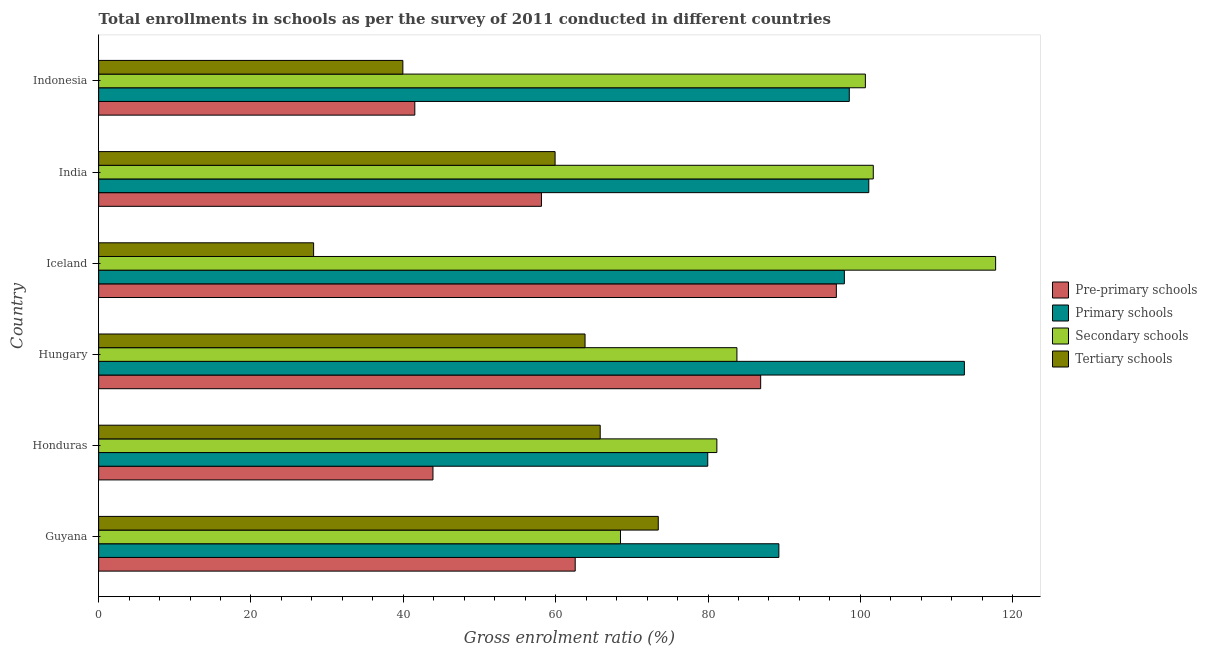How many different coloured bars are there?
Ensure brevity in your answer.  4. Are the number of bars per tick equal to the number of legend labels?
Keep it short and to the point. Yes. What is the label of the 1st group of bars from the top?
Give a very brief answer. Indonesia. In how many cases, is the number of bars for a given country not equal to the number of legend labels?
Keep it short and to the point. 0. What is the gross enrolment ratio in pre-primary schools in Guyana?
Your answer should be compact. 62.57. Across all countries, what is the maximum gross enrolment ratio in pre-primary schools?
Provide a short and direct response. 96.85. Across all countries, what is the minimum gross enrolment ratio in tertiary schools?
Give a very brief answer. 28.22. In which country was the gross enrolment ratio in primary schools minimum?
Ensure brevity in your answer.  Honduras. What is the total gross enrolment ratio in secondary schools in the graph?
Offer a very short reply. 553.58. What is the difference between the gross enrolment ratio in tertiary schools in Hungary and that in India?
Your answer should be very brief. 3.93. What is the difference between the gross enrolment ratio in primary schools in Guyana and the gross enrolment ratio in secondary schools in Iceland?
Your response must be concise. -28.45. What is the average gross enrolment ratio in tertiary schools per country?
Your answer should be very brief. 55.21. What is the difference between the gross enrolment ratio in tertiary schools and gross enrolment ratio in secondary schools in India?
Ensure brevity in your answer.  -41.77. In how many countries, is the gross enrolment ratio in secondary schools greater than 20 %?
Ensure brevity in your answer.  6. What is the ratio of the gross enrolment ratio in secondary schools in Hungary to that in India?
Offer a terse response. 0.82. Is the gross enrolment ratio in primary schools in Guyana less than that in Indonesia?
Your response must be concise. Yes. What is the difference between the highest and the second highest gross enrolment ratio in pre-primary schools?
Your response must be concise. 9.94. What is the difference between the highest and the lowest gross enrolment ratio in tertiary schools?
Offer a terse response. 45.25. Is it the case that in every country, the sum of the gross enrolment ratio in secondary schools and gross enrolment ratio in tertiary schools is greater than the sum of gross enrolment ratio in pre-primary schools and gross enrolment ratio in primary schools?
Make the answer very short. No. What does the 3rd bar from the top in Guyana represents?
Offer a very short reply. Primary schools. What does the 3rd bar from the bottom in Honduras represents?
Keep it short and to the point. Secondary schools. How many bars are there?
Give a very brief answer. 24. Are all the bars in the graph horizontal?
Keep it short and to the point. Yes. Are the values on the major ticks of X-axis written in scientific E-notation?
Provide a short and direct response. No. Where does the legend appear in the graph?
Keep it short and to the point. Center right. What is the title of the graph?
Give a very brief answer. Total enrollments in schools as per the survey of 2011 conducted in different countries. Does "UNAIDS" appear as one of the legend labels in the graph?
Keep it short and to the point. No. What is the label or title of the X-axis?
Ensure brevity in your answer.  Gross enrolment ratio (%). What is the label or title of the Y-axis?
Your response must be concise. Country. What is the Gross enrolment ratio (%) of Pre-primary schools in Guyana?
Offer a terse response. 62.57. What is the Gross enrolment ratio (%) in Primary schools in Guyana?
Offer a very short reply. 89.3. What is the Gross enrolment ratio (%) of Secondary schools in Guyana?
Provide a short and direct response. 68.51. What is the Gross enrolment ratio (%) of Tertiary schools in Guyana?
Offer a very short reply. 73.47. What is the Gross enrolment ratio (%) of Pre-primary schools in Honduras?
Provide a short and direct response. 43.89. What is the Gross enrolment ratio (%) in Primary schools in Honduras?
Offer a terse response. 79.97. What is the Gross enrolment ratio (%) of Secondary schools in Honduras?
Keep it short and to the point. 81.16. What is the Gross enrolment ratio (%) of Tertiary schools in Honduras?
Keep it short and to the point. 65.85. What is the Gross enrolment ratio (%) in Pre-primary schools in Hungary?
Ensure brevity in your answer.  86.91. What is the Gross enrolment ratio (%) in Primary schools in Hungary?
Make the answer very short. 113.66. What is the Gross enrolment ratio (%) of Secondary schools in Hungary?
Your response must be concise. 83.8. What is the Gross enrolment ratio (%) of Tertiary schools in Hungary?
Provide a succinct answer. 63.86. What is the Gross enrolment ratio (%) in Pre-primary schools in Iceland?
Make the answer very short. 96.85. What is the Gross enrolment ratio (%) in Primary schools in Iceland?
Your response must be concise. 97.9. What is the Gross enrolment ratio (%) of Secondary schools in Iceland?
Provide a succinct answer. 117.76. What is the Gross enrolment ratio (%) of Tertiary schools in Iceland?
Ensure brevity in your answer.  28.22. What is the Gross enrolment ratio (%) in Pre-primary schools in India?
Offer a terse response. 58.13. What is the Gross enrolment ratio (%) of Primary schools in India?
Make the answer very short. 101.11. What is the Gross enrolment ratio (%) of Secondary schools in India?
Your answer should be very brief. 101.7. What is the Gross enrolment ratio (%) in Tertiary schools in India?
Provide a succinct answer. 59.92. What is the Gross enrolment ratio (%) of Pre-primary schools in Indonesia?
Offer a terse response. 41.51. What is the Gross enrolment ratio (%) in Primary schools in Indonesia?
Ensure brevity in your answer.  98.55. What is the Gross enrolment ratio (%) of Secondary schools in Indonesia?
Provide a short and direct response. 100.66. What is the Gross enrolment ratio (%) of Tertiary schools in Indonesia?
Provide a succinct answer. 39.94. Across all countries, what is the maximum Gross enrolment ratio (%) of Pre-primary schools?
Keep it short and to the point. 96.85. Across all countries, what is the maximum Gross enrolment ratio (%) of Primary schools?
Offer a terse response. 113.66. Across all countries, what is the maximum Gross enrolment ratio (%) of Secondary schools?
Provide a succinct answer. 117.76. Across all countries, what is the maximum Gross enrolment ratio (%) in Tertiary schools?
Give a very brief answer. 73.47. Across all countries, what is the minimum Gross enrolment ratio (%) in Pre-primary schools?
Keep it short and to the point. 41.51. Across all countries, what is the minimum Gross enrolment ratio (%) in Primary schools?
Offer a very short reply. 79.97. Across all countries, what is the minimum Gross enrolment ratio (%) in Secondary schools?
Offer a terse response. 68.51. Across all countries, what is the minimum Gross enrolment ratio (%) of Tertiary schools?
Provide a succinct answer. 28.22. What is the total Gross enrolment ratio (%) of Pre-primary schools in the graph?
Your response must be concise. 389.86. What is the total Gross enrolment ratio (%) in Primary schools in the graph?
Your answer should be very brief. 580.48. What is the total Gross enrolment ratio (%) of Secondary schools in the graph?
Keep it short and to the point. 553.58. What is the total Gross enrolment ratio (%) of Tertiary schools in the graph?
Keep it short and to the point. 331.26. What is the difference between the Gross enrolment ratio (%) in Pre-primary schools in Guyana and that in Honduras?
Offer a terse response. 18.67. What is the difference between the Gross enrolment ratio (%) in Primary schools in Guyana and that in Honduras?
Provide a short and direct response. 9.34. What is the difference between the Gross enrolment ratio (%) in Secondary schools in Guyana and that in Honduras?
Provide a succinct answer. -12.65. What is the difference between the Gross enrolment ratio (%) of Tertiary schools in Guyana and that in Honduras?
Offer a very short reply. 7.62. What is the difference between the Gross enrolment ratio (%) in Pre-primary schools in Guyana and that in Hungary?
Provide a succinct answer. -24.35. What is the difference between the Gross enrolment ratio (%) of Primary schools in Guyana and that in Hungary?
Ensure brevity in your answer.  -24.35. What is the difference between the Gross enrolment ratio (%) in Secondary schools in Guyana and that in Hungary?
Keep it short and to the point. -15.29. What is the difference between the Gross enrolment ratio (%) of Tertiary schools in Guyana and that in Hungary?
Provide a short and direct response. 9.61. What is the difference between the Gross enrolment ratio (%) in Pre-primary schools in Guyana and that in Iceland?
Keep it short and to the point. -34.28. What is the difference between the Gross enrolment ratio (%) of Primary schools in Guyana and that in Iceland?
Offer a very short reply. -8.6. What is the difference between the Gross enrolment ratio (%) of Secondary schools in Guyana and that in Iceland?
Your response must be concise. -49.25. What is the difference between the Gross enrolment ratio (%) in Tertiary schools in Guyana and that in Iceland?
Provide a succinct answer. 45.25. What is the difference between the Gross enrolment ratio (%) in Pre-primary schools in Guyana and that in India?
Give a very brief answer. 4.43. What is the difference between the Gross enrolment ratio (%) of Primary schools in Guyana and that in India?
Offer a very short reply. -11.8. What is the difference between the Gross enrolment ratio (%) in Secondary schools in Guyana and that in India?
Your response must be concise. -33.19. What is the difference between the Gross enrolment ratio (%) of Tertiary schools in Guyana and that in India?
Offer a terse response. 13.55. What is the difference between the Gross enrolment ratio (%) of Pre-primary schools in Guyana and that in Indonesia?
Provide a short and direct response. 21.06. What is the difference between the Gross enrolment ratio (%) in Primary schools in Guyana and that in Indonesia?
Your answer should be very brief. -9.24. What is the difference between the Gross enrolment ratio (%) in Secondary schools in Guyana and that in Indonesia?
Your answer should be very brief. -32.15. What is the difference between the Gross enrolment ratio (%) of Tertiary schools in Guyana and that in Indonesia?
Offer a very short reply. 33.53. What is the difference between the Gross enrolment ratio (%) of Pre-primary schools in Honduras and that in Hungary?
Offer a very short reply. -43.02. What is the difference between the Gross enrolment ratio (%) in Primary schools in Honduras and that in Hungary?
Make the answer very short. -33.69. What is the difference between the Gross enrolment ratio (%) in Secondary schools in Honduras and that in Hungary?
Your answer should be very brief. -2.63. What is the difference between the Gross enrolment ratio (%) of Tertiary schools in Honduras and that in Hungary?
Your answer should be compact. 1.99. What is the difference between the Gross enrolment ratio (%) of Pre-primary schools in Honduras and that in Iceland?
Offer a terse response. -52.96. What is the difference between the Gross enrolment ratio (%) of Primary schools in Honduras and that in Iceland?
Your response must be concise. -17.93. What is the difference between the Gross enrolment ratio (%) in Secondary schools in Honduras and that in Iceland?
Your answer should be compact. -36.6. What is the difference between the Gross enrolment ratio (%) of Tertiary schools in Honduras and that in Iceland?
Your response must be concise. 37.62. What is the difference between the Gross enrolment ratio (%) of Pre-primary schools in Honduras and that in India?
Your answer should be compact. -14.24. What is the difference between the Gross enrolment ratio (%) of Primary schools in Honduras and that in India?
Give a very brief answer. -21.14. What is the difference between the Gross enrolment ratio (%) of Secondary schools in Honduras and that in India?
Offer a terse response. -20.54. What is the difference between the Gross enrolment ratio (%) in Tertiary schools in Honduras and that in India?
Make the answer very short. 5.92. What is the difference between the Gross enrolment ratio (%) of Pre-primary schools in Honduras and that in Indonesia?
Your response must be concise. 2.38. What is the difference between the Gross enrolment ratio (%) of Primary schools in Honduras and that in Indonesia?
Your answer should be compact. -18.58. What is the difference between the Gross enrolment ratio (%) in Secondary schools in Honduras and that in Indonesia?
Your response must be concise. -19.5. What is the difference between the Gross enrolment ratio (%) of Tertiary schools in Honduras and that in Indonesia?
Provide a succinct answer. 25.91. What is the difference between the Gross enrolment ratio (%) in Pre-primary schools in Hungary and that in Iceland?
Ensure brevity in your answer.  -9.94. What is the difference between the Gross enrolment ratio (%) in Primary schools in Hungary and that in Iceland?
Provide a succinct answer. 15.76. What is the difference between the Gross enrolment ratio (%) of Secondary schools in Hungary and that in Iceland?
Provide a succinct answer. -33.96. What is the difference between the Gross enrolment ratio (%) of Tertiary schools in Hungary and that in Iceland?
Keep it short and to the point. 35.63. What is the difference between the Gross enrolment ratio (%) of Pre-primary schools in Hungary and that in India?
Your answer should be compact. 28.78. What is the difference between the Gross enrolment ratio (%) in Primary schools in Hungary and that in India?
Offer a very short reply. 12.55. What is the difference between the Gross enrolment ratio (%) in Secondary schools in Hungary and that in India?
Your answer should be very brief. -17.9. What is the difference between the Gross enrolment ratio (%) of Tertiary schools in Hungary and that in India?
Offer a very short reply. 3.93. What is the difference between the Gross enrolment ratio (%) in Pre-primary schools in Hungary and that in Indonesia?
Make the answer very short. 45.41. What is the difference between the Gross enrolment ratio (%) of Primary schools in Hungary and that in Indonesia?
Make the answer very short. 15.11. What is the difference between the Gross enrolment ratio (%) in Secondary schools in Hungary and that in Indonesia?
Provide a succinct answer. -16.86. What is the difference between the Gross enrolment ratio (%) of Tertiary schools in Hungary and that in Indonesia?
Offer a very short reply. 23.92. What is the difference between the Gross enrolment ratio (%) in Pre-primary schools in Iceland and that in India?
Ensure brevity in your answer.  38.72. What is the difference between the Gross enrolment ratio (%) of Primary schools in Iceland and that in India?
Your answer should be very brief. -3.21. What is the difference between the Gross enrolment ratio (%) of Secondary schools in Iceland and that in India?
Keep it short and to the point. 16.06. What is the difference between the Gross enrolment ratio (%) in Tertiary schools in Iceland and that in India?
Provide a succinct answer. -31.7. What is the difference between the Gross enrolment ratio (%) of Pre-primary schools in Iceland and that in Indonesia?
Ensure brevity in your answer.  55.34. What is the difference between the Gross enrolment ratio (%) of Primary schools in Iceland and that in Indonesia?
Your response must be concise. -0.65. What is the difference between the Gross enrolment ratio (%) of Secondary schools in Iceland and that in Indonesia?
Keep it short and to the point. 17.1. What is the difference between the Gross enrolment ratio (%) of Tertiary schools in Iceland and that in Indonesia?
Offer a terse response. -11.72. What is the difference between the Gross enrolment ratio (%) in Pre-primary schools in India and that in Indonesia?
Give a very brief answer. 16.63. What is the difference between the Gross enrolment ratio (%) in Primary schools in India and that in Indonesia?
Keep it short and to the point. 2.56. What is the difference between the Gross enrolment ratio (%) of Secondary schools in India and that in Indonesia?
Your response must be concise. 1.04. What is the difference between the Gross enrolment ratio (%) of Tertiary schools in India and that in Indonesia?
Provide a succinct answer. 19.99. What is the difference between the Gross enrolment ratio (%) of Pre-primary schools in Guyana and the Gross enrolment ratio (%) of Primary schools in Honduras?
Make the answer very short. -17.4. What is the difference between the Gross enrolment ratio (%) in Pre-primary schools in Guyana and the Gross enrolment ratio (%) in Secondary schools in Honduras?
Your answer should be compact. -18.6. What is the difference between the Gross enrolment ratio (%) in Pre-primary schools in Guyana and the Gross enrolment ratio (%) in Tertiary schools in Honduras?
Provide a succinct answer. -3.28. What is the difference between the Gross enrolment ratio (%) in Primary schools in Guyana and the Gross enrolment ratio (%) in Secondary schools in Honduras?
Offer a terse response. 8.14. What is the difference between the Gross enrolment ratio (%) in Primary schools in Guyana and the Gross enrolment ratio (%) in Tertiary schools in Honduras?
Your response must be concise. 23.46. What is the difference between the Gross enrolment ratio (%) of Secondary schools in Guyana and the Gross enrolment ratio (%) of Tertiary schools in Honduras?
Offer a very short reply. 2.66. What is the difference between the Gross enrolment ratio (%) in Pre-primary schools in Guyana and the Gross enrolment ratio (%) in Primary schools in Hungary?
Provide a short and direct response. -51.09. What is the difference between the Gross enrolment ratio (%) of Pre-primary schools in Guyana and the Gross enrolment ratio (%) of Secondary schools in Hungary?
Provide a succinct answer. -21.23. What is the difference between the Gross enrolment ratio (%) in Pre-primary schools in Guyana and the Gross enrolment ratio (%) in Tertiary schools in Hungary?
Ensure brevity in your answer.  -1.29. What is the difference between the Gross enrolment ratio (%) in Primary schools in Guyana and the Gross enrolment ratio (%) in Secondary schools in Hungary?
Offer a terse response. 5.51. What is the difference between the Gross enrolment ratio (%) of Primary schools in Guyana and the Gross enrolment ratio (%) of Tertiary schools in Hungary?
Give a very brief answer. 25.45. What is the difference between the Gross enrolment ratio (%) of Secondary schools in Guyana and the Gross enrolment ratio (%) of Tertiary schools in Hungary?
Make the answer very short. 4.65. What is the difference between the Gross enrolment ratio (%) in Pre-primary schools in Guyana and the Gross enrolment ratio (%) in Primary schools in Iceland?
Your answer should be compact. -35.33. What is the difference between the Gross enrolment ratio (%) of Pre-primary schools in Guyana and the Gross enrolment ratio (%) of Secondary schools in Iceland?
Your answer should be very brief. -55.19. What is the difference between the Gross enrolment ratio (%) of Pre-primary schools in Guyana and the Gross enrolment ratio (%) of Tertiary schools in Iceland?
Offer a terse response. 34.34. What is the difference between the Gross enrolment ratio (%) of Primary schools in Guyana and the Gross enrolment ratio (%) of Secondary schools in Iceland?
Your answer should be very brief. -28.45. What is the difference between the Gross enrolment ratio (%) of Primary schools in Guyana and the Gross enrolment ratio (%) of Tertiary schools in Iceland?
Offer a very short reply. 61.08. What is the difference between the Gross enrolment ratio (%) of Secondary schools in Guyana and the Gross enrolment ratio (%) of Tertiary schools in Iceland?
Make the answer very short. 40.29. What is the difference between the Gross enrolment ratio (%) in Pre-primary schools in Guyana and the Gross enrolment ratio (%) in Primary schools in India?
Make the answer very short. -38.54. What is the difference between the Gross enrolment ratio (%) of Pre-primary schools in Guyana and the Gross enrolment ratio (%) of Secondary schools in India?
Offer a terse response. -39.13. What is the difference between the Gross enrolment ratio (%) of Pre-primary schools in Guyana and the Gross enrolment ratio (%) of Tertiary schools in India?
Keep it short and to the point. 2.64. What is the difference between the Gross enrolment ratio (%) in Primary schools in Guyana and the Gross enrolment ratio (%) in Secondary schools in India?
Offer a terse response. -12.39. What is the difference between the Gross enrolment ratio (%) in Primary schools in Guyana and the Gross enrolment ratio (%) in Tertiary schools in India?
Provide a short and direct response. 29.38. What is the difference between the Gross enrolment ratio (%) in Secondary schools in Guyana and the Gross enrolment ratio (%) in Tertiary schools in India?
Ensure brevity in your answer.  8.59. What is the difference between the Gross enrolment ratio (%) in Pre-primary schools in Guyana and the Gross enrolment ratio (%) in Primary schools in Indonesia?
Keep it short and to the point. -35.98. What is the difference between the Gross enrolment ratio (%) in Pre-primary schools in Guyana and the Gross enrolment ratio (%) in Secondary schools in Indonesia?
Your answer should be compact. -38.09. What is the difference between the Gross enrolment ratio (%) in Pre-primary schools in Guyana and the Gross enrolment ratio (%) in Tertiary schools in Indonesia?
Offer a terse response. 22.63. What is the difference between the Gross enrolment ratio (%) of Primary schools in Guyana and the Gross enrolment ratio (%) of Secondary schools in Indonesia?
Offer a very short reply. -11.35. What is the difference between the Gross enrolment ratio (%) of Primary schools in Guyana and the Gross enrolment ratio (%) of Tertiary schools in Indonesia?
Your answer should be compact. 49.37. What is the difference between the Gross enrolment ratio (%) in Secondary schools in Guyana and the Gross enrolment ratio (%) in Tertiary schools in Indonesia?
Offer a very short reply. 28.57. What is the difference between the Gross enrolment ratio (%) of Pre-primary schools in Honduras and the Gross enrolment ratio (%) of Primary schools in Hungary?
Provide a short and direct response. -69.76. What is the difference between the Gross enrolment ratio (%) of Pre-primary schools in Honduras and the Gross enrolment ratio (%) of Secondary schools in Hungary?
Keep it short and to the point. -39.91. What is the difference between the Gross enrolment ratio (%) in Pre-primary schools in Honduras and the Gross enrolment ratio (%) in Tertiary schools in Hungary?
Give a very brief answer. -19.97. What is the difference between the Gross enrolment ratio (%) of Primary schools in Honduras and the Gross enrolment ratio (%) of Secondary schools in Hungary?
Provide a succinct answer. -3.83. What is the difference between the Gross enrolment ratio (%) in Primary schools in Honduras and the Gross enrolment ratio (%) in Tertiary schools in Hungary?
Your answer should be very brief. 16.11. What is the difference between the Gross enrolment ratio (%) of Secondary schools in Honduras and the Gross enrolment ratio (%) of Tertiary schools in Hungary?
Provide a succinct answer. 17.3. What is the difference between the Gross enrolment ratio (%) in Pre-primary schools in Honduras and the Gross enrolment ratio (%) in Primary schools in Iceland?
Provide a short and direct response. -54.01. What is the difference between the Gross enrolment ratio (%) in Pre-primary schools in Honduras and the Gross enrolment ratio (%) in Secondary schools in Iceland?
Make the answer very short. -73.87. What is the difference between the Gross enrolment ratio (%) in Pre-primary schools in Honduras and the Gross enrolment ratio (%) in Tertiary schools in Iceland?
Your response must be concise. 15.67. What is the difference between the Gross enrolment ratio (%) of Primary schools in Honduras and the Gross enrolment ratio (%) of Secondary schools in Iceland?
Give a very brief answer. -37.79. What is the difference between the Gross enrolment ratio (%) of Primary schools in Honduras and the Gross enrolment ratio (%) of Tertiary schools in Iceland?
Offer a very short reply. 51.74. What is the difference between the Gross enrolment ratio (%) in Secondary schools in Honduras and the Gross enrolment ratio (%) in Tertiary schools in Iceland?
Give a very brief answer. 52.94. What is the difference between the Gross enrolment ratio (%) in Pre-primary schools in Honduras and the Gross enrolment ratio (%) in Primary schools in India?
Provide a succinct answer. -57.22. What is the difference between the Gross enrolment ratio (%) in Pre-primary schools in Honduras and the Gross enrolment ratio (%) in Secondary schools in India?
Your answer should be very brief. -57.81. What is the difference between the Gross enrolment ratio (%) of Pre-primary schools in Honduras and the Gross enrolment ratio (%) of Tertiary schools in India?
Provide a short and direct response. -16.03. What is the difference between the Gross enrolment ratio (%) of Primary schools in Honduras and the Gross enrolment ratio (%) of Secondary schools in India?
Provide a short and direct response. -21.73. What is the difference between the Gross enrolment ratio (%) in Primary schools in Honduras and the Gross enrolment ratio (%) in Tertiary schools in India?
Give a very brief answer. 20.04. What is the difference between the Gross enrolment ratio (%) in Secondary schools in Honduras and the Gross enrolment ratio (%) in Tertiary schools in India?
Give a very brief answer. 21.24. What is the difference between the Gross enrolment ratio (%) of Pre-primary schools in Honduras and the Gross enrolment ratio (%) of Primary schools in Indonesia?
Your answer should be very brief. -54.66. What is the difference between the Gross enrolment ratio (%) of Pre-primary schools in Honduras and the Gross enrolment ratio (%) of Secondary schools in Indonesia?
Offer a very short reply. -56.77. What is the difference between the Gross enrolment ratio (%) of Pre-primary schools in Honduras and the Gross enrolment ratio (%) of Tertiary schools in Indonesia?
Offer a very short reply. 3.95. What is the difference between the Gross enrolment ratio (%) of Primary schools in Honduras and the Gross enrolment ratio (%) of Secondary schools in Indonesia?
Ensure brevity in your answer.  -20.69. What is the difference between the Gross enrolment ratio (%) of Primary schools in Honduras and the Gross enrolment ratio (%) of Tertiary schools in Indonesia?
Make the answer very short. 40.03. What is the difference between the Gross enrolment ratio (%) in Secondary schools in Honduras and the Gross enrolment ratio (%) in Tertiary schools in Indonesia?
Your answer should be very brief. 41.22. What is the difference between the Gross enrolment ratio (%) in Pre-primary schools in Hungary and the Gross enrolment ratio (%) in Primary schools in Iceland?
Your answer should be very brief. -10.99. What is the difference between the Gross enrolment ratio (%) of Pre-primary schools in Hungary and the Gross enrolment ratio (%) of Secondary schools in Iceland?
Make the answer very short. -30.85. What is the difference between the Gross enrolment ratio (%) of Pre-primary schools in Hungary and the Gross enrolment ratio (%) of Tertiary schools in Iceland?
Keep it short and to the point. 58.69. What is the difference between the Gross enrolment ratio (%) in Primary schools in Hungary and the Gross enrolment ratio (%) in Secondary schools in Iceland?
Make the answer very short. -4.1. What is the difference between the Gross enrolment ratio (%) of Primary schools in Hungary and the Gross enrolment ratio (%) of Tertiary schools in Iceland?
Give a very brief answer. 85.43. What is the difference between the Gross enrolment ratio (%) of Secondary schools in Hungary and the Gross enrolment ratio (%) of Tertiary schools in Iceland?
Offer a terse response. 55.57. What is the difference between the Gross enrolment ratio (%) in Pre-primary schools in Hungary and the Gross enrolment ratio (%) in Primary schools in India?
Offer a very short reply. -14.19. What is the difference between the Gross enrolment ratio (%) of Pre-primary schools in Hungary and the Gross enrolment ratio (%) of Secondary schools in India?
Make the answer very short. -14.78. What is the difference between the Gross enrolment ratio (%) of Pre-primary schools in Hungary and the Gross enrolment ratio (%) of Tertiary schools in India?
Your answer should be very brief. 26.99. What is the difference between the Gross enrolment ratio (%) in Primary schools in Hungary and the Gross enrolment ratio (%) in Secondary schools in India?
Provide a succinct answer. 11.96. What is the difference between the Gross enrolment ratio (%) in Primary schools in Hungary and the Gross enrolment ratio (%) in Tertiary schools in India?
Offer a terse response. 53.73. What is the difference between the Gross enrolment ratio (%) in Secondary schools in Hungary and the Gross enrolment ratio (%) in Tertiary schools in India?
Ensure brevity in your answer.  23.87. What is the difference between the Gross enrolment ratio (%) in Pre-primary schools in Hungary and the Gross enrolment ratio (%) in Primary schools in Indonesia?
Make the answer very short. -11.63. What is the difference between the Gross enrolment ratio (%) in Pre-primary schools in Hungary and the Gross enrolment ratio (%) in Secondary schools in Indonesia?
Give a very brief answer. -13.75. What is the difference between the Gross enrolment ratio (%) of Pre-primary schools in Hungary and the Gross enrolment ratio (%) of Tertiary schools in Indonesia?
Keep it short and to the point. 46.97. What is the difference between the Gross enrolment ratio (%) of Primary schools in Hungary and the Gross enrolment ratio (%) of Secondary schools in Indonesia?
Offer a terse response. 13. What is the difference between the Gross enrolment ratio (%) of Primary schools in Hungary and the Gross enrolment ratio (%) of Tertiary schools in Indonesia?
Offer a very short reply. 73.72. What is the difference between the Gross enrolment ratio (%) in Secondary schools in Hungary and the Gross enrolment ratio (%) in Tertiary schools in Indonesia?
Your answer should be compact. 43.86. What is the difference between the Gross enrolment ratio (%) of Pre-primary schools in Iceland and the Gross enrolment ratio (%) of Primary schools in India?
Your answer should be compact. -4.26. What is the difference between the Gross enrolment ratio (%) in Pre-primary schools in Iceland and the Gross enrolment ratio (%) in Secondary schools in India?
Your response must be concise. -4.85. What is the difference between the Gross enrolment ratio (%) in Pre-primary schools in Iceland and the Gross enrolment ratio (%) in Tertiary schools in India?
Provide a succinct answer. 36.93. What is the difference between the Gross enrolment ratio (%) in Primary schools in Iceland and the Gross enrolment ratio (%) in Secondary schools in India?
Ensure brevity in your answer.  -3.8. What is the difference between the Gross enrolment ratio (%) in Primary schools in Iceland and the Gross enrolment ratio (%) in Tertiary schools in India?
Provide a succinct answer. 37.98. What is the difference between the Gross enrolment ratio (%) of Secondary schools in Iceland and the Gross enrolment ratio (%) of Tertiary schools in India?
Your response must be concise. 57.84. What is the difference between the Gross enrolment ratio (%) of Pre-primary schools in Iceland and the Gross enrolment ratio (%) of Primary schools in Indonesia?
Keep it short and to the point. -1.7. What is the difference between the Gross enrolment ratio (%) of Pre-primary schools in Iceland and the Gross enrolment ratio (%) of Secondary schools in Indonesia?
Make the answer very short. -3.81. What is the difference between the Gross enrolment ratio (%) of Pre-primary schools in Iceland and the Gross enrolment ratio (%) of Tertiary schools in Indonesia?
Offer a terse response. 56.91. What is the difference between the Gross enrolment ratio (%) of Primary schools in Iceland and the Gross enrolment ratio (%) of Secondary schools in Indonesia?
Ensure brevity in your answer.  -2.76. What is the difference between the Gross enrolment ratio (%) in Primary schools in Iceland and the Gross enrolment ratio (%) in Tertiary schools in Indonesia?
Provide a succinct answer. 57.96. What is the difference between the Gross enrolment ratio (%) of Secondary schools in Iceland and the Gross enrolment ratio (%) of Tertiary schools in Indonesia?
Provide a short and direct response. 77.82. What is the difference between the Gross enrolment ratio (%) of Pre-primary schools in India and the Gross enrolment ratio (%) of Primary schools in Indonesia?
Make the answer very short. -40.41. What is the difference between the Gross enrolment ratio (%) in Pre-primary schools in India and the Gross enrolment ratio (%) in Secondary schools in Indonesia?
Offer a terse response. -42.52. What is the difference between the Gross enrolment ratio (%) in Pre-primary schools in India and the Gross enrolment ratio (%) in Tertiary schools in Indonesia?
Your answer should be very brief. 18.2. What is the difference between the Gross enrolment ratio (%) of Primary schools in India and the Gross enrolment ratio (%) of Secondary schools in Indonesia?
Your answer should be very brief. 0.45. What is the difference between the Gross enrolment ratio (%) in Primary schools in India and the Gross enrolment ratio (%) in Tertiary schools in Indonesia?
Offer a terse response. 61.17. What is the difference between the Gross enrolment ratio (%) in Secondary schools in India and the Gross enrolment ratio (%) in Tertiary schools in Indonesia?
Provide a succinct answer. 61.76. What is the average Gross enrolment ratio (%) in Pre-primary schools per country?
Keep it short and to the point. 64.98. What is the average Gross enrolment ratio (%) in Primary schools per country?
Your answer should be compact. 96.75. What is the average Gross enrolment ratio (%) in Secondary schools per country?
Provide a short and direct response. 92.26. What is the average Gross enrolment ratio (%) in Tertiary schools per country?
Make the answer very short. 55.21. What is the difference between the Gross enrolment ratio (%) in Pre-primary schools and Gross enrolment ratio (%) in Primary schools in Guyana?
Offer a very short reply. -26.74. What is the difference between the Gross enrolment ratio (%) in Pre-primary schools and Gross enrolment ratio (%) in Secondary schools in Guyana?
Give a very brief answer. -5.94. What is the difference between the Gross enrolment ratio (%) in Pre-primary schools and Gross enrolment ratio (%) in Tertiary schools in Guyana?
Give a very brief answer. -10.91. What is the difference between the Gross enrolment ratio (%) of Primary schools and Gross enrolment ratio (%) of Secondary schools in Guyana?
Offer a terse response. 20.79. What is the difference between the Gross enrolment ratio (%) of Primary schools and Gross enrolment ratio (%) of Tertiary schools in Guyana?
Provide a short and direct response. 15.83. What is the difference between the Gross enrolment ratio (%) of Secondary schools and Gross enrolment ratio (%) of Tertiary schools in Guyana?
Your answer should be very brief. -4.96. What is the difference between the Gross enrolment ratio (%) in Pre-primary schools and Gross enrolment ratio (%) in Primary schools in Honduras?
Keep it short and to the point. -36.07. What is the difference between the Gross enrolment ratio (%) of Pre-primary schools and Gross enrolment ratio (%) of Secondary schools in Honduras?
Offer a terse response. -37.27. What is the difference between the Gross enrolment ratio (%) in Pre-primary schools and Gross enrolment ratio (%) in Tertiary schools in Honduras?
Give a very brief answer. -21.96. What is the difference between the Gross enrolment ratio (%) of Primary schools and Gross enrolment ratio (%) of Secondary schools in Honduras?
Offer a terse response. -1.2. What is the difference between the Gross enrolment ratio (%) in Primary schools and Gross enrolment ratio (%) in Tertiary schools in Honduras?
Make the answer very short. 14.12. What is the difference between the Gross enrolment ratio (%) of Secondary schools and Gross enrolment ratio (%) of Tertiary schools in Honduras?
Give a very brief answer. 15.32. What is the difference between the Gross enrolment ratio (%) in Pre-primary schools and Gross enrolment ratio (%) in Primary schools in Hungary?
Keep it short and to the point. -26.74. What is the difference between the Gross enrolment ratio (%) of Pre-primary schools and Gross enrolment ratio (%) of Secondary schools in Hungary?
Your answer should be very brief. 3.12. What is the difference between the Gross enrolment ratio (%) of Pre-primary schools and Gross enrolment ratio (%) of Tertiary schools in Hungary?
Keep it short and to the point. 23.06. What is the difference between the Gross enrolment ratio (%) of Primary schools and Gross enrolment ratio (%) of Secondary schools in Hungary?
Offer a terse response. 29.86. What is the difference between the Gross enrolment ratio (%) of Primary schools and Gross enrolment ratio (%) of Tertiary schools in Hungary?
Your answer should be very brief. 49.8. What is the difference between the Gross enrolment ratio (%) of Secondary schools and Gross enrolment ratio (%) of Tertiary schools in Hungary?
Your answer should be compact. 19.94. What is the difference between the Gross enrolment ratio (%) in Pre-primary schools and Gross enrolment ratio (%) in Primary schools in Iceland?
Your answer should be very brief. -1.05. What is the difference between the Gross enrolment ratio (%) in Pre-primary schools and Gross enrolment ratio (%) in Secondary schools in Iceland?
Make the answer very short. -20.91. What is the difference between the Gross enrolment ratio (%) in Pre-primary schools and Gross enrolment ratio (%) in Tertiary schools in Iceland?
Your answer should be compact. 68.63. What is the difference between the Gross enrolment ratio (%) of Primary schools and Gross enrolment ratio (%) of Secondary schools in Iceland?
Your answer should be very brief. -19.86. What is the difference between the Gross enrolment ratio (%) of Primary schools and Gross enrolment ratio (%) of Tertiary schools in Iceland?
Provide a succinct answer. 69.68. What is the difference between the Gross enrolment ratio (%) in Secondary schools and Gross enrolment ratio (%) in Tertiary schools in Iceland?
Keep it short and to the point. 89.54. What is the difference between the Gross enrolment ratio (%) in Pre-primary schools and Gross enrolment ratio (%) in Primary schools in India?
Your answer should be compact. -42.97. What is the difference between the Gross enrolment ratio (%) of Pre-primary schools and Gross enrolment ratio (%) of Secondary schools in India?
Provide a short and direct response. -43.56. What is the difference between the Gross enrolment ratio (%) of Pre-primary schools and Gross enrolment ratio (%) of Tertiary schools in India?
Ensure brevity in your answer.  -1.79. What is the difference between the Gross enrolment ratio (%) in Primary schools and Gross enrolment ratio (%) in Secondary schools in India?
Your answer should be very brief. -0.59. What is the difference between the Gross enrolment ratio (%) of Primary schools and Gross enrolment ratio (%) of Tertiary schools in India?
Offer a very short reply. 41.18. What is the difference between the Gross enrolment ratio (%) in Secondary schools and Gross enrolment ratio (%) in Tertiary schools in India?
Keep it short and to the point. 41.77. What is the difference between the Gross enrolment ratio (%) in Pre-primary schools and Gross enrolment ratio (%) in Primary schools in Indonesia?
Give a very brief answer. -57.04. What is the difference between the Gross enrolment ratio (%) in Pre-primary schools and Gross enrolment ratio (%) in Secondary schools in Indonesia?
Give a very brief answer. -59.15. What is the difference between the Gross enrolment ratio (%) of Pre-primary schools and Gross enrolment ratio (%) of Tertiary schools in Indonesia?
Ensure brevity in your answer.  1.57. What is the difference between the Gross enrolment ratio (%) of Primary schools and Gross enrolment ratio (%) of Secondary schools in Indonesia?
Your response must be concise. -2.11. What is the difference between the Gross enrolment ratio (%) in Primary schools and Gross enrolment ratio (%) in Tertiary schools in Indonesia?
Provide a short and direct response. 58.61. What is the difference between the Gross enrolment ratio (%) of Secondary schools and Gross enrolment ratio (%) of Tertiary schools in Indonesia?
Your answer should be compact. 60.72. What is the ratio of the Gross enrolment ratio (%) in Pre-primary schools in Guyana to that in Honduras?
Your answer should be very brief. 1.43. What is the ratio of the Gross enrolment ratio (%) in Primary schools in Guyana to that in Honduras?
Ensure brevity in your answer.  1.12. What is the ratio of the Gross enrolment ratio (%) in Secondary schools in Guyana to that in Honduras?
Your response must be concise. 0.84. What is the ratio of the Gross enrolment ratio (%) of Tertiary schools in Guyana to that in Honduras?
Offer a terse response. 1.12. What is the ratio of the Gross enrolment ratio (%) of Pre-primary schools in Guyana to that in Hungary?
Ensure brevity in your answer.  0.72. What is the ratio of the Gross enrolment ratio (%) of Primary schools in Guyana to that in Hungary?
Give a very brief answer. 0.79. What is the ratio of the Gross enrolment ratio (%) in Secondary schools in Guyana to that in Hungary?
Provide a succinct answer. 0.82. What is the ratio of the Gross enrolment ratio (%) in Tertiary schools in Guyana to that in Hungary?
Offer a terse response. 1.15. What is the ratio of the Gross enrolment ratio (%) of Pre-primary schools in Guyana to that in Iceland?
Offer a very short reply. 0.65. What is the ratio of the Gross enrolment ratio (%) in Primary schools in Guyana to that in Iceland?
Keep it short and to the point. 0.91. What is the ratio of the Gross enrolment ratio (%) in Secondary schools in Guyana to that in Iceland?
Your answer should be very brief. 0.58. What is the ratio of the Gross enrolment ratio (%) of Tertiary schools in Guyana to that in Iceland?
Ensure brevity in your answer.  2.6. What is the ratio of the Gross enrolment ratio (%) in Pre-primary schools in Guyana to that in India?
Provide a short and direct response. 1.08. What is the ratio of the Gross enrolment ratio (%) of Primary schools in Guyana to that in India?
Your response must be concise. 0.88. What is the ratio of the Gross enrolment ratio (%) of Secondary schools in Guyana to that in India?
Make the answer very short. 0.67. What is the ratio of the Gross enrolment ratio (%) of Tertiary schools in Guyana to that in India?
Provide a succinct answer. 1.23. What is the ratio of the Gross enrolment ratio (%) in Pre-primary schools in Guyana to that in Indonesia?
Give a very brief answer. 1.51. What is the ratio of the Gross enrolment ratio (%) in Primary schools in Guyana to that in Indonesia?
Your answer should be compact. 0.91. What is the ratio of the Gross enrolment ratio (%) of Secondary schools in Guyana to that in Indonesia?
Offer a terse response. 0.68. What is the ratio of the Gross enrolment ratio (%) in Tertiary schools in Guyana to that in Indonesia?
Your answer should be compact. 1.84. What is the ratio of the Gross enrolment ratio (%) in Pre-primary schools in Honduras to that in Hungary?
Give a very brief answer. 0.51. What is the ratio of the Gross enrolment ratio (%) in Primary schools in Honduras to that in Hungary?
Your answer should be compact. 0.7. What is the ratio of the Gross enrolment ratio (%) of Secondary schools in Honduras to that in Hungary?
Offer a terse response. 0.97. What is the ratio of the Gross enrolment ratio (%) of Tertiary schools in Honduras to that in Hungary?
Your answer should be very brief. 1.03. What is the ratio of the Gross enrolment ratio (%) in Pre-primary schools in Honduras to that in Iceland?
Your response must be concise. 0.45. What is the ratio of the Gross enrolment ratio (%) of Primary schools in Honduras to that in Iceland?
Your response must be concise. 0.82. What is the ratio of the Gross enrolment ratio (%) in Secondary schools in Honduras to that in Iceland?
Offer a very short reply. 0.69. What is the ratio of the Gross enrolment ratio (%) in Tertiary schools in Honduras to that in Iceland?
Your answer should be compact. 2.33. What is the ratio of the Gross enrolment ratio (%) of Pre-primary schools in Honduras to that in India?
Offer a very short reply. 0.76. What is the ratio of the Gross enrolment ratio (%) in Primary schools in Honduras to that in India?
Make the answer very short. 0.79. What is the ratio of the Gross enrolment ratio (%) in Secondary schools in Honduras to that in India?
Ensure brevity in your answer.  0.8. What is the ratio of the Gross enrolment ratio (%) of Tertiary schools in Honduras to that in India?
Make the answer very short. 1.1. What is the ratio of the Gross enrolment ratio (%) of Pre-primary schools in Honduras to that in Indonesia?
Your answer should be compact. 1.06. What is the ratio of the Gross enrolment ratio (%) of Primary schools in Honduras to that in Indonesia?
Your answer should be very brief. 0.81. What is the ratio of the Gross enrolment ratio (%) of Secondary schools in Honduras to that in Indonesia?
Give a very brief answer. 0.81. What is the ratio of the Gross enrolment ratio (%) of Tertiary schools in Honduras to that in Indonesia?
Offer a terse response. 1.65. What is the ratio of the Gross enrolment ratio (%) of Pre-primary schools in Hungary to that in Iceland?
Your answer should be very brief. 0.9. What is the ratio of the Gross enrolment ratio (%) of Primary schools in Hungary to that in Iceland?
Your answer should be compact. 1.16. What is the ratio of the Gross enrolment ratio (%) in Secondary schools in Hungary to that in Iceland?
Your response must be concise. 0.71. What is the ratio of the Gross enrolment ratio (%) of Tertiary schools in Hungary to that in Iceland?
Offer a very short reply. 2.26. What is the ratio of the Gross enrolment ratio (%) in Pre-primary schools in Hungary to that in India?
Provide a short and direct response. 1.5. What is the ratio of the Gross enrolment ratio (%) in Primary schools in Hungary to that in India?
Offer a very short reply. 1.12. What is the ratio of the Gross enrolment ratio (%) of Secondary schools in Hungary to that in India?
Provide a short and direct response. 0.82. What is the ratio of the Gross enrolment ratio (%) in Tertiary schools in Hungary to that in India?
Your answer should be compact. 1.07. What is the ratio of the Gross enrolment ratio (%) of Pre-primary schools in Hungary to that in Indonesia?
Ensure brevity in your answer.  2.09. What is the ratio of the Gross enrolment ratio (%) of Primary schools in Hungary to that in Indonesia?
Offer a terse response. 1.15. What is the ratio of the Gross enrolment ratio (%) of Secondary schools in Hungary to that in Indonesia?
Offer a very short reply. 0.83. What is the ratio of the Gross enrolment ratio (%) of Tertiary schools in Hungary to that in Indonesia?
Your answer should be very brief. 1.6. What is the ratio of the Gross enrolment ratio (%) in Pre-primary schools in Iceland to that in India?
Offer a very short reply. 1.67. What is the ratio of the Gross enrolment ratio (%) in Primary schools in Iceland to that in India?
Give a very brief answer. 0.97. What is the ratio of the Gross enrolment ratio (%) in Secondary schools in Iceland to that in India?
Keep it short and to the point. 1.16. What is the ratio of the Gross enrolment ratio (%) in Tertiary schools in Iceland to that in India?
Make the answer very short. 0.47. What is the ratio of the Gross enrolment ratio (%) in Pre-primary schools in Iceland to that in Indonesia?
Offer a very short reply. 2.33. What is the ratio of the Gross enrolment ratio (%) of Secondary schools in Iceland to that in Indonesia?
Your response must be concise. 1.17. What is the ratio of the Gross enrolment ratio (%) in Tertiary schools in Iceland to that in Indonesia?
Ensure brevity in your answer.  0.71. What is the ratio of the Gross enrolment ratio (%) in Pre-primary schools in India to that in Indonesia?
Ensure brevity in your answer.  1.4. What is the ratio of the Gross enrolment ratio (%) of Primary schools in India to that in Indonesia?
Your answer should be compact. 1.03. What is the ratio of the Gross enrolment ratio (%) of Secondary schools in India to that in Indonesia?
Offer a very short reply. 1.01. What is the ratio of the Gross enrolment ratio (%) in Tertiary schools in India to that in Indonesia?
Give a very brief answer. 1.5. What is the difference between the highest and the second highest Gross enrolment ratio (%) of Pre-primary schools?
Offer a terse response. 9.94. What is the difference between the highest and the second highest Gross enrolment ratio (%) of Primary schools?
Give a very brief answer. 12.55. What is the difference between the highest and the second highest Gross enrolment ratio (%) of Secondary schools?
Your answer should be very brief. 16.06. What is the difference between the highest and the second highest Gross enrolment ratio (%) of Tertiary schools?
Offer a terse response. 7.62. What is the difference between the highest and the lowest Gross enrolment ratio (%) of Pre-primary schools?
Provide a succinct answer. 55.34. What is the difference between the highest and the lowest Gross enrolment ratio (%) in Primary schools?
Offer a terse response. 33.69. What is the difference between the highest and the lowest Gross enrolment ratio (%) of Secondary schools?
Provide a short and direct response. 49.25. What is the difference between the highest and the lowest Gross enrolment ratio (%) in Tertiary schools?
Offer a very short reply. 45.25. 